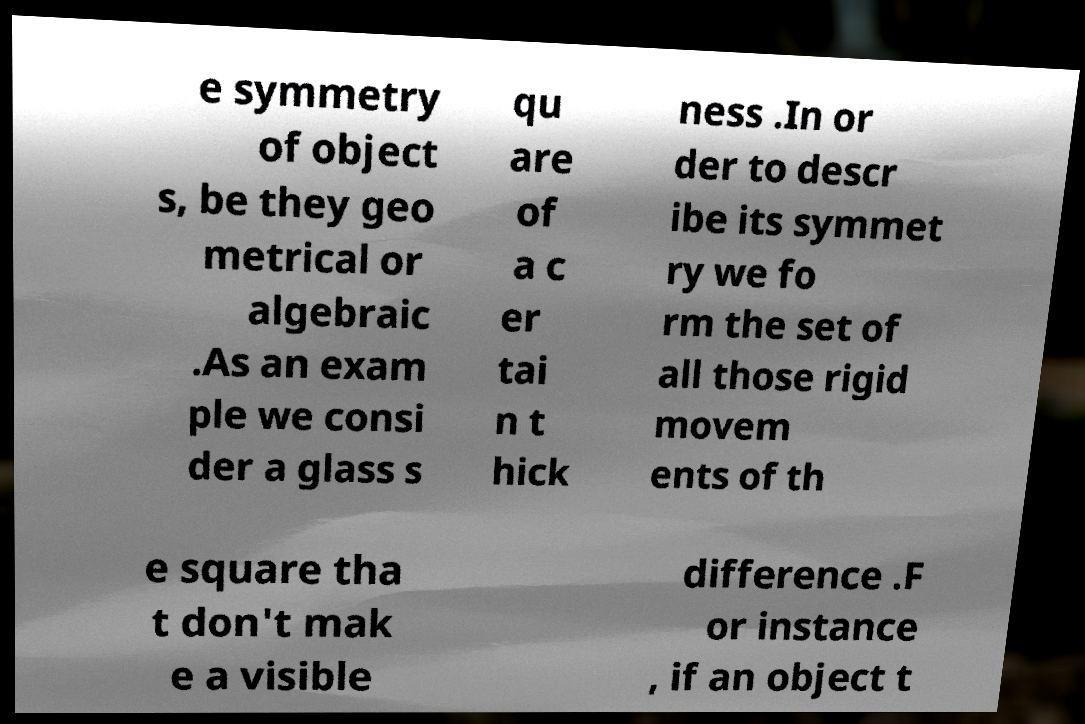What messages or text are displayed in this image? I need them in a readable, typed format. e symmetry of object s, be they geo metrical or algebraic .As an exam ple we consi der a glass s qu are of a c er tai n t hick ness .In or der to descr ibe its symmet ry we fo rm the set of all those rigid movem ents of th e square tha t don't mak e a visible difference .F or instance , if an object t 